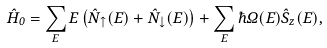Convert formula to latex. <formula><loc_0><loc_0><loc_500><loc_500>\hat { H } _ { 0 } = \sum _ { E } E \left ( \hat { N } _ { \uparrow } ( E ) + \hat { N } _ { \downarrow } ( E ) \right ) + \sum _ { E } \hbar { \Omega } ( E ) \hat { S } _ { z } ( E ) ,</formula> 